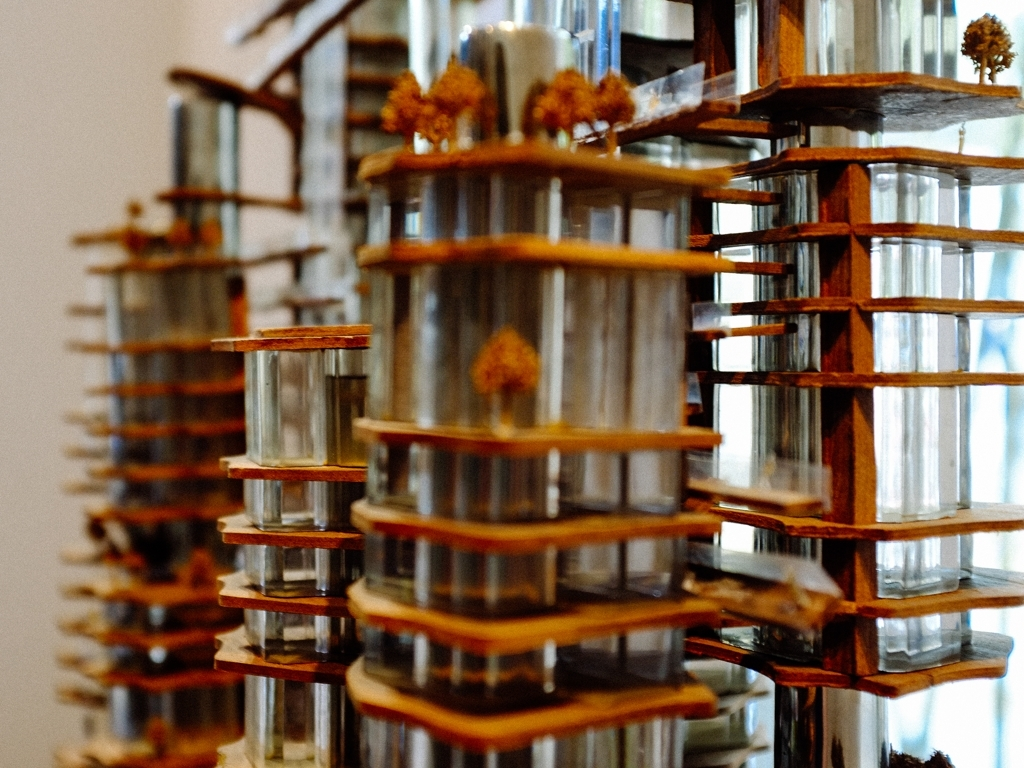Can you describe what this structure is meant to simulate or represent? The image showcases an artistic installation resembling a collection of miniature buildings or platforms, with each layer potentially representing a floor or a separate space within a larger construct. The cylindrical shapes could evoke images of futuristic habitats or models for urban planning. It's a visually intriguing piece that invites viewers to contemplate the use of space and structure in architecture. What do you think the materials used in this structure might signify? The use of wood and glass in this structure likely points to a contrast between organic and manufactured elements, perhaps suggesting a dialogue between nature and human-made environments. Wood brings warmth and a natural touch to the installation, while the glass introduces transparency and modernity, sparking a conversation about sustainability and the harmonious integration of architecture with the natural world. 